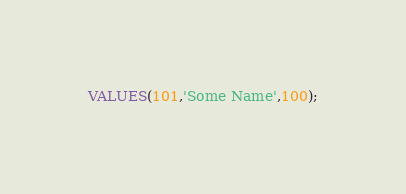Convert code to text. <code><loc_0><loc_0><loc_500><loc_500><_SQL_>VALUES(101,'Some Name',100);</code> 